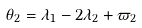Convert formula to latex. <formula><loc_0><loc_0><loc_500><loc_500>\theta _ { 2 } = \lambda _ { 1 } - 2 \lambda _ { 2 } + \varpi _ { 2 }</formula> 